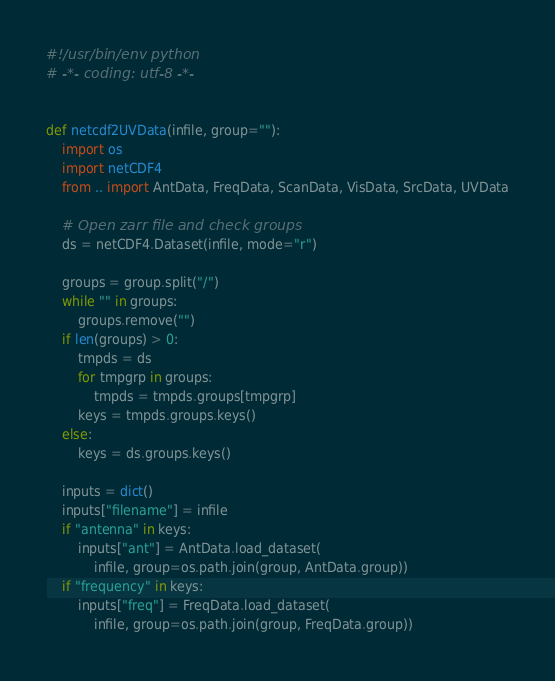Convert code to text. <code><loc_0><loc_0><loc_500><loc_500><_Python_>#!/usr/bin/env python
# -*- coding: utf-8 -*-


def netcdf2UVData(infile, group=""):
    import os
    import netCDF4
    from .. import AntData, FreqData, ScanData, VisData, SrcData, UVData

    # Open zarr file and check groups
    ds = netCDF4.Dataset(infile, mode="r")

    groups = group.split("/")
    while "" in groups:
        groups.remove("")
    if len(groups) > 0:
        tmpds = ds
        for tmpgrp in groups:
            tmpds = tmpds.groups[tmpgrp]
        keys = tmpds.groups.keys()
    else:
        keys = ds.groups.keys()

    inputs = dict()
    inputs["filename"] = infile
    if "antenna" in keys:
        inputs["ant"] = AntData.load_dataset(
            infile, group=os.path.join(group, AntData.group))
    if "frequency" in keys:
        inputs["freq"] = FreqData.load_dataset(
            infile, group=os.path.join(group, FreqData.group))</code> 